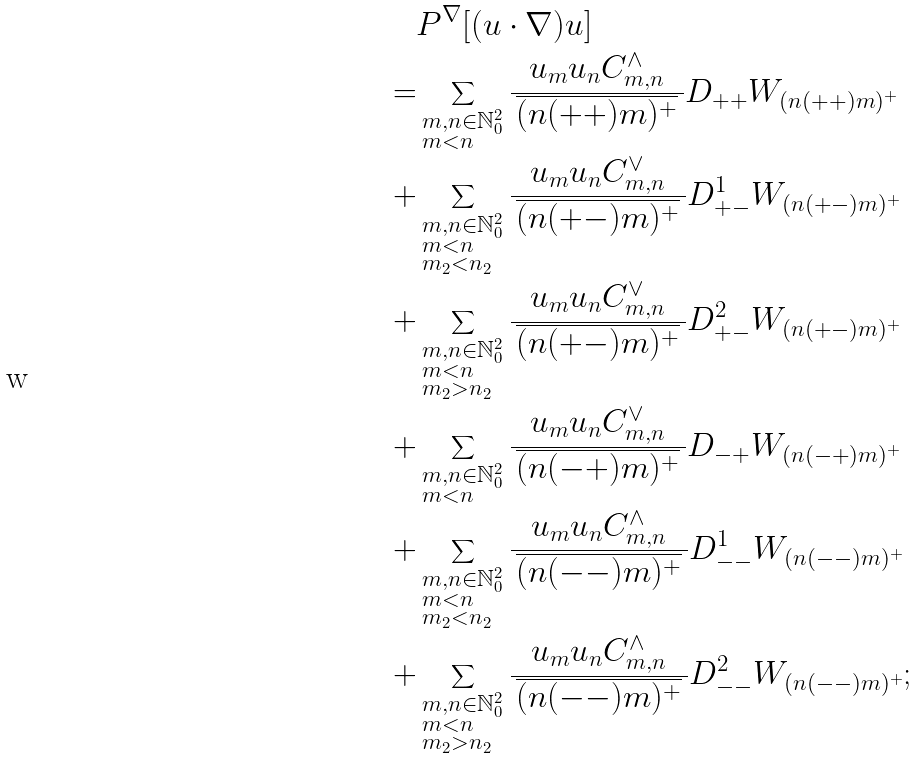<formula> <loc_0><loc_0><loc_500><loc_500>& P ^ { \nabla } [ ( u \cdot \nabla ) u ] \\ = & \sum _ { \begin{subarray} { l } m , n \in \mathbb { N } _ { 0 } ^ { 2 } \\ m < n \end{subarray} } \frac { u _ { m } u _ { n } C _ { m , n } ^ { \wedge } } { \, \overline { ( n ( + + ) m ) ^ { + } } \, } D _ { + + } W _ { ( n ( + + ) m ) ^ { + } } \\ + & \sum _ { \begin{subarray} { l } m , n \in \mathbb { N } _ { 0 } ^ { 2 } \\ m < n \\ m _ { 2 } < n _ { 2 } \end{subarray} } \frac { u _ { m } u _ { n } C _ { m , n } ^ { \vee } } { \, \overline { ( n ( + - ) m ) ^ { + } } \, } D _ { + - } ^ { 1 } W _ { ( n ( + - ) m ) ^ { + } } \\ + & \sum _ { \begin{subarray} { l } m , n \in \mathbb { N } _ { 0 } ^ { 2 } \\ m < n \\ m _ { 2 } > n _ { 2 } \end{subarray} } \frac { u _ { m } u _ { n } C _ { m , n } ^ { \vee } } { \, \overline { ( n ( + - ) m ) ^ { + } } \, } D _ { + - } ^ { 2 } W _ { ( n ( + - ) m ) ^ { + } } \\ + & \sum _ { \begin{subarray} { l } m , n \in \mathbb { N } _ { 0 } ^ { 2 } \\ m < n \end{subarray} } \frac { u _ { m } u _ { n } C _ { m , n } ^ { \vee } } { \, \overline { ( n ( - + ) m ) ^ { + } } \, } D _ { - + } W _ { ( n ( - + ) m ) ^ { + } } \\ + & \sum _ { \begin{subarray} { l } m , n \in \mathbb { N } _ { 0 } ^ { 2 } \\ m < n \\ m _ { 2 } < n _ { 2 } \end{subarray} } \frac { u _ { m } u _ { n } C _ { m , n } ^ { \wedge } } { \, \overline { ( n ( - - ) m ) ^ { + } } \, } D _ { - - } ^ { 1 } W _ { ( n ( - - ) m ) ^ { + } } \\ + & \sum _ { \begin{subarray} { l } m , n \in \mathbb { N } _ { 0 } ^ { 2 } \\ m < n \\ m _ { 2 } > n _ { 2 } \end{subarray} } \frac { u _ { m } u _ { n } C _ { m , n } ^ { \wedge } } { \, \overline { ( n ( - - ) m ) ^ { + } } \, } D _ { - - } ^ { 2 } W _ { ( n ( - - ) m ) ^ { + } } ;</formula> 